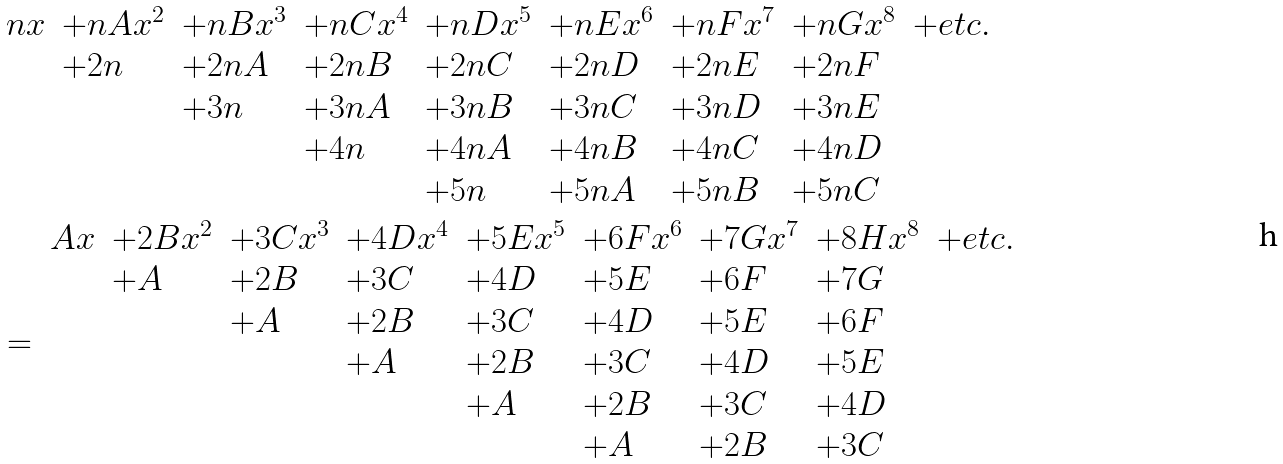Convert formula to latex. <formula><loc_0><loc_0><loc_500><loc_500>& \begin{array} { l l l l l l l l l } n x & + n A x ^ { 2 } & + n B x ^ { 3 } & + n C x ^ { 4 } & + n D x ^ { 5 } & + n E x ^ { 6 } & + n F x ^ { 7 } & + n G x ^ { 8 } & + e t c . \\ & + 2 n & + 2 n A & + 2 n B & + 2 n C & + 2 n D & + 2 n E & + 2 n F & \\ & & + 3 n & + 3 n A & + 3 n B & + 3 n C & + 3 n D & + 3 n E & \\ & & & + 4 n & + 4 n A & + 4 n B & + 4 n C & + 4 n D & \\ & & & & + 5 n & + 5 n A & + 5 n B & + 5 n C & \end{array} \\ & = \begin{array} { l l l l l l l l l } A x & + 2 B x ^ { 2 } & + 3 C x ^ { 3 } & + 4 D x ^ { 4 } & + 5 E x ^ { 5 } & + 6 F x ^ { 6 } & + 7 G x ^ { 7 } & + 8 H x ^ { 8 } & + e t c . \\ & + A & + 2 B & + 3 C & + 4 D & + 5 E & + 6 F & + 7 G & \\ & & + A & + 2 B & + 3 C & + 4 D & + 5 E & + 6 F & \\ & & & + A & + 2 B & + 3 C & + 4 D & + 5 E & \\ & & & & + A & + 2 B & + 3 C & + 4 D & \\ & & & & & + A & + 2 B & + 3 C & \end{array}</formula> 